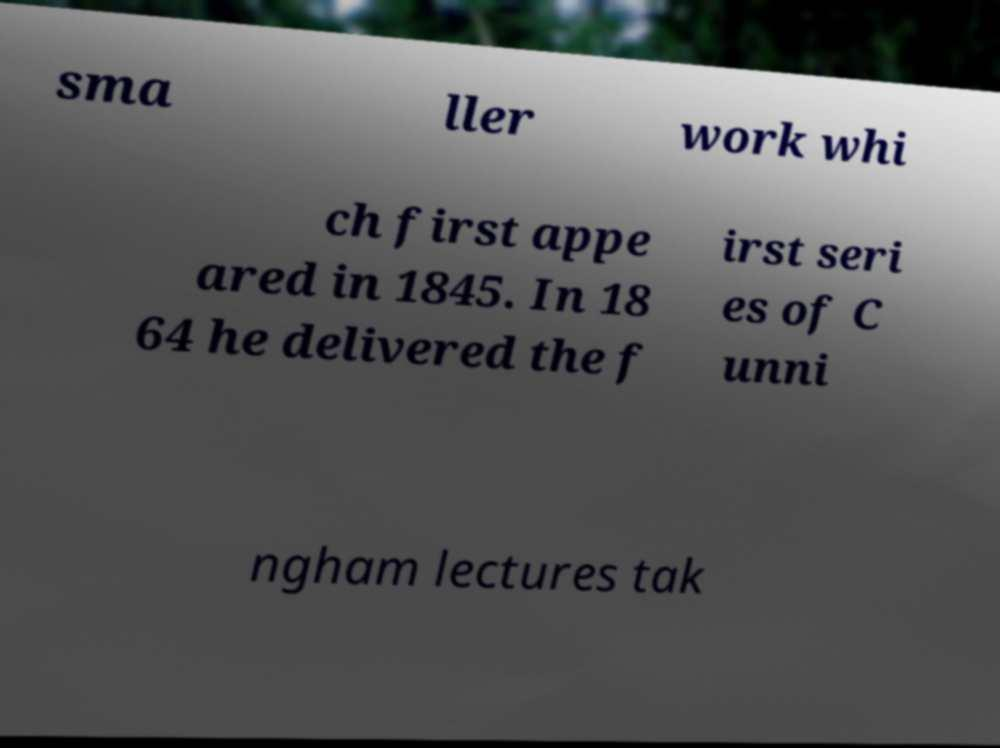What messages or text are displayed in this image? I need them in a readable, typed format. sma ller work whi ch first appe ared in 1845. In 18 64 he delivered the f irst seri es of C unni ngham lectures tak 